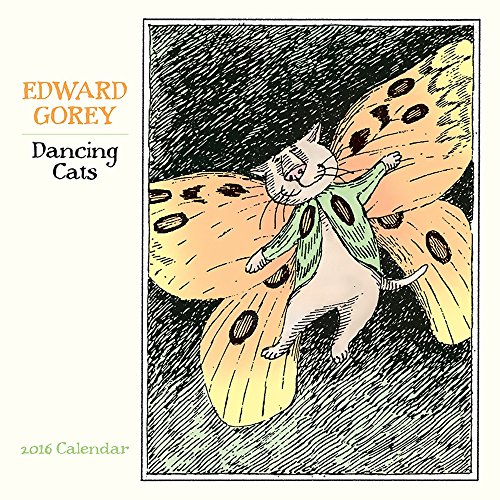What type of book is this? This book is a calendar, specifically designed to offer both utility in keeping track of dates and aesthetic pleasure with the unique illustrations for each month. 